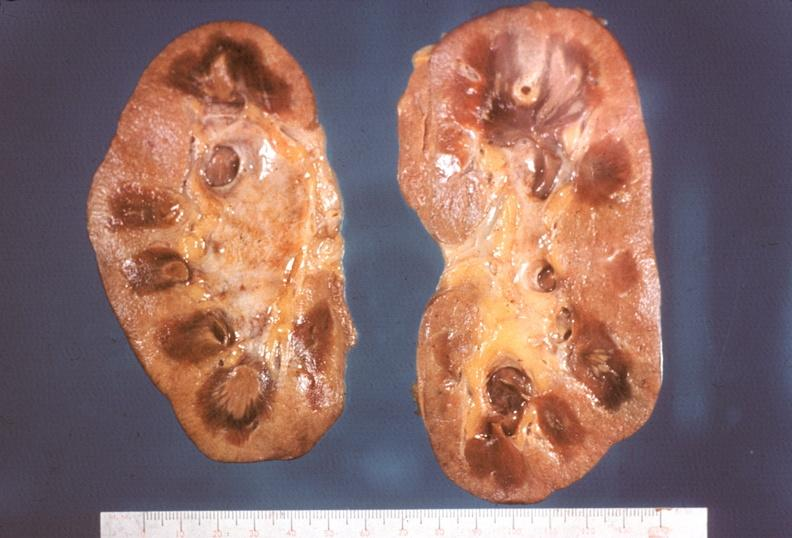does this image show kidney, papillitis, necrotizing?
Answer the question using a single word or phrase. Yes 